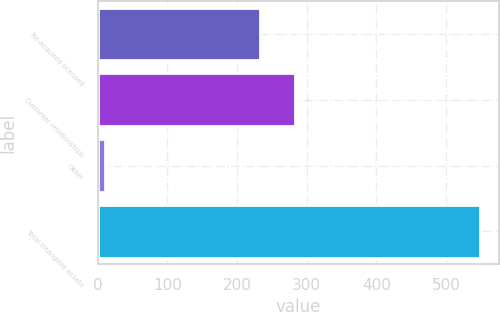Convert chart to OTSL. <chart><loc_0><loc_0><loc_500><loc_500><bar_chart><fcel>Re-acquired licensed<fcel>Customer relationships<fcel>Other<fcel>Total intangible assets<nl><fcel>232.7<fcel>282.35<fcel>10.1<fcel>548.95<nl></chart> 